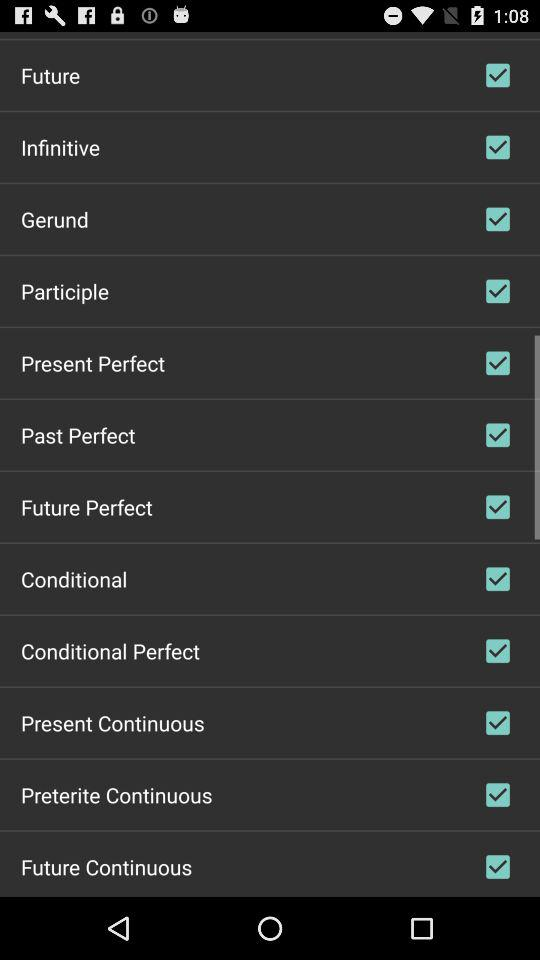What is the status of "Gerund"? The status is "on". 